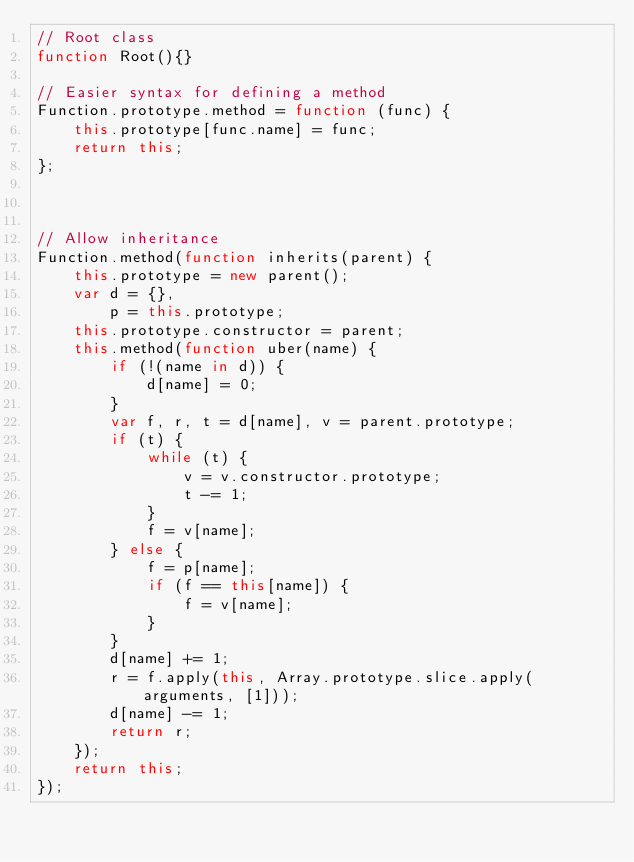Convert code to text. <code><loc_0><loc_0><loc_500><loc_500><_JavaScript_>// Root class
function Root(){}

// Easier syntax for defining a method
Function.prototype.method = function (func) {
    this.prototype[func.name] = func;
    return this;
};



// Allow inheritance
Function.method(function inherits(parent) {
    this.prototype = new parent();
    var d = {}, 
        p = this.prototype;
    this.prototype.constructor = parent; 
    this.method(function uber(name) {
        if (!(name in d)) {
            d[name] = 0;
        }        
        var f, r, t = d[name], v = parent.prototype;
        if (t) {
            while (t) {
                v = v.constructor.prototype;
                t -= 1;
            }
            f = v[name];
        } else {
            f = p[name];
            if (f == this[name]) {
                f = v[name];
            }
        }
        d[name] += 1;
        r = f.apply(this, Array.prototype.slice.apply(arguments, [1]));
        d[name] -= 1;
        return r;
    });
    return this;
});
</code> 